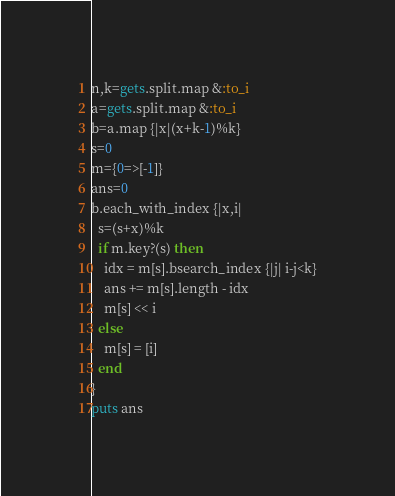Convert code to text. <code><loc_0><loc_0><loc_500><loc_500><_Ruby_>n,k=gets.split.map &:to_i
a=gets.split.map &:to_i
b=a.map {|x|(x+k-1)%k}
s=0
m={0=>[-1]}
ans=0
b.each_with_index {|x,i|
  s=(s+x)%k
  if m.key?(s) then
    idx = m[s].bsearch_index {|j| i-j<k}
    ans += m[s].length - idx
    m[s] << i
  else
    m[s] = [i]
  end
}
puts ans
</code> 